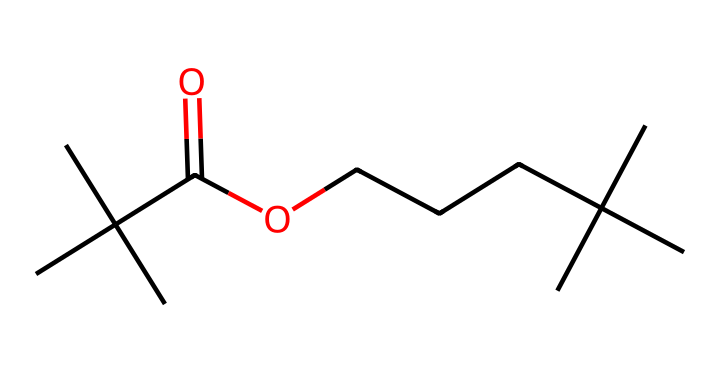What is the main functional group in this chemical? The chemical structure shows a carboxylic acid functional group, indicated by the presence of the -COOH part at one end, which contains a carbonyl (C=O) and a hydroxyl (-OH) group.
Answer: carboxylic acid How many carbon atoms are present in this structure? By analyzing the chemical structure representation, we can see a total of 12 carbon atoms connected in various branched formats, which can be counted from the structure.
Answer: 12 What is the longest continuous carbon chain in this molecule? By tracing through the molecule, the longest continuous chain can be identified as containing 5 carbon atoms, which occurs in the middle of the branching.
Answer: 5 What type of solid does this chemical most likely represent? Given the presence of multiple alkyl chains and a carboxylic acid group, this molecule is indicative of a type of wax or resin, which typically forms a solid state at room temperature.
Answer: wax Are there any double bonds present in this chemical? In examining the structure, the only existing double bond is part of the carboxylic acid group where the carbon is double-bonded to an oxygen (C=O), confirming the presence of one double bond.
Answer: yes 